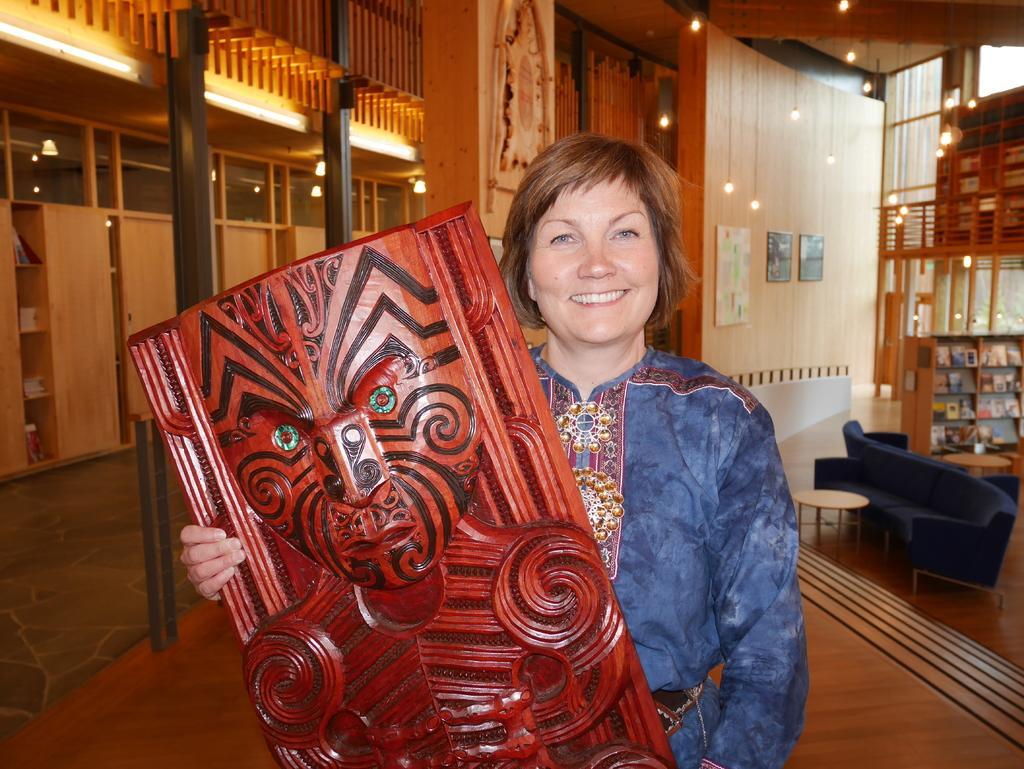Can you describe this image briefly? a person is standing holding a wooden object in her hand. behind her there is a blue sofa at the right and bookshelves. there are lights hanging on the top. 